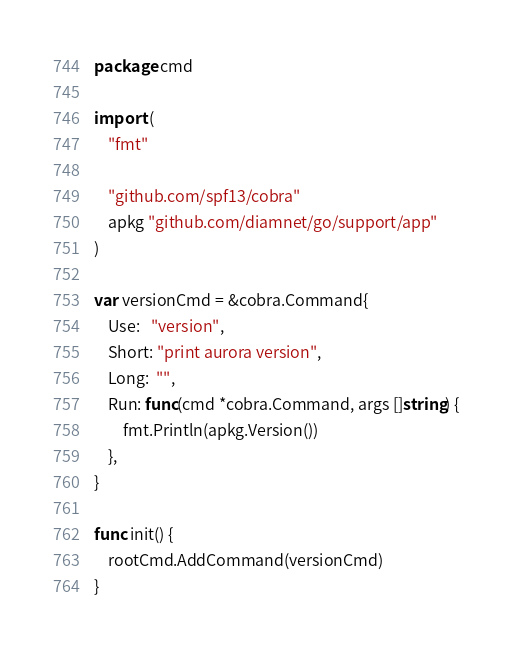Convert code to text. <code><loc_0><loc_0><loc_500><loc_500><_Go_>package cmd

import (
	"fmt"

	"github.com/spf13/cobra"
	apkg "github.com/diamnet/go/support/app"
)

var versionCmd = &cobra.Command{
	Use:   "version",
	Short: "print aurora version",
	Long:  "",
	Run: func(cmd *cobra.Command, args []string) {
		fmt.Println(apkg.Version())
	},
}

func init() {
	rootCmd.AddCommand(versionCmd)
}
</code> 